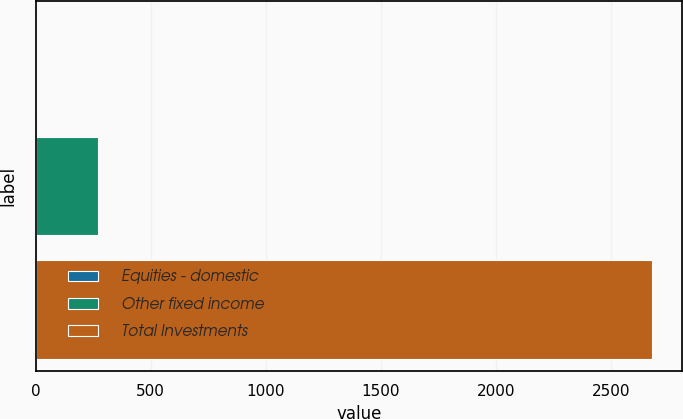Convert chart. <chart><loc_0><loc_0><loc_500><loc_500><bar_chart><fcel>Equities - domestic<fcel>Other fixed income<fcel>Total Investments<nl><fcel>1<fcel>268.6<fcel>2677<nl></chart> 